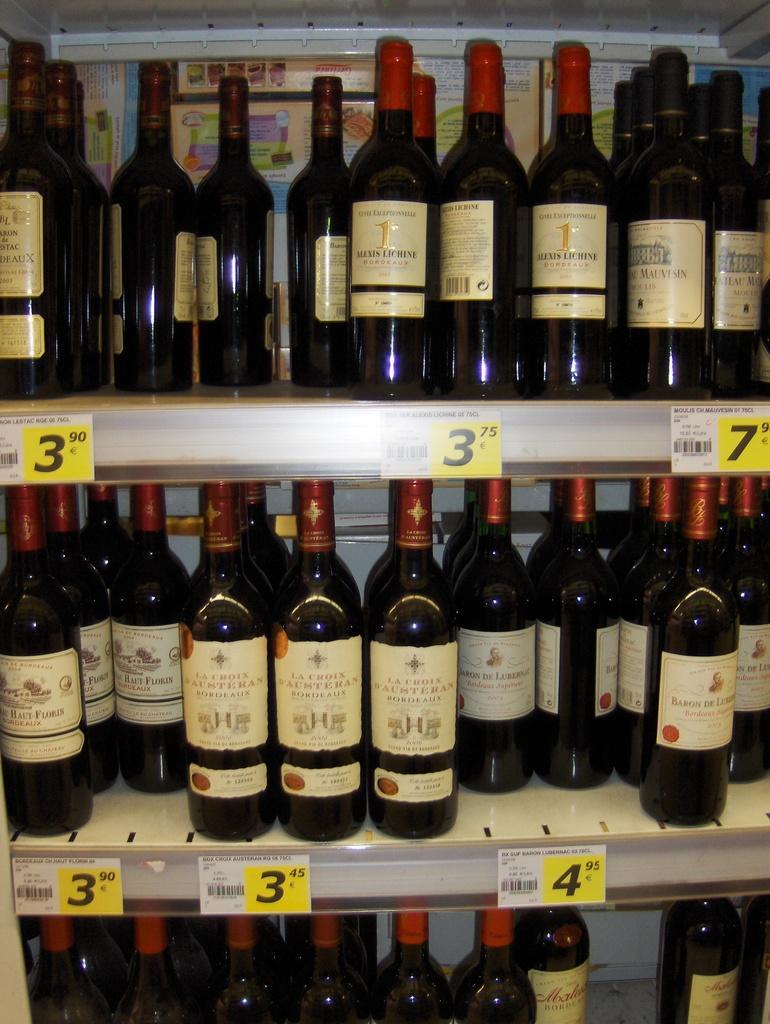Could you give a brief overview of what you see in this image? In this image there are bottles in the cupboard. 